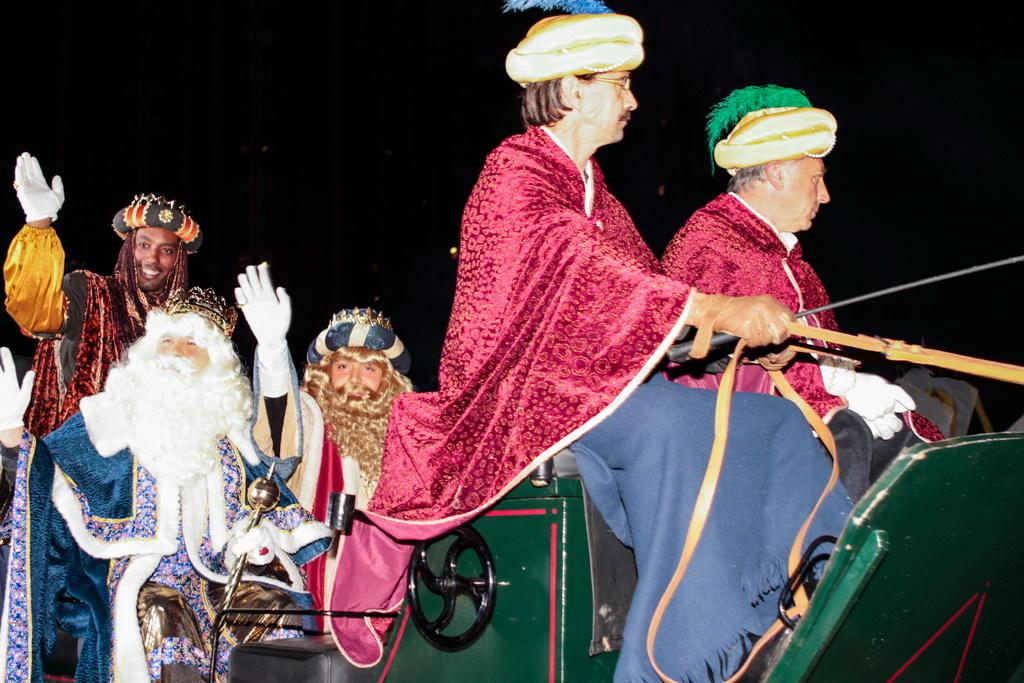What are the people in the image doing? The people in the image are sitting on a cart. What are the two people holding in the image? Two people are holding objects in the image. What can be observed about the lighting in the image? The background of the image is dark. What type of drug can be seen in the image? There is no drug present in the image. What is the bed used for in the image? There is no bed present in the image. 